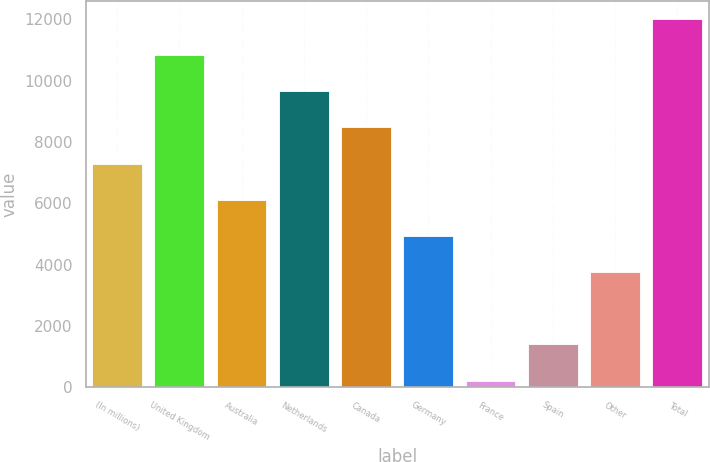Convert chart to OTSL. <chart><loc_0><loc_0><loc_500><loc_500><bar_chart><fcel>(In millions)<fcel>United Kingdom<fcel>Australia<fcel>Netherlands<fcel>Canada<fcel>Germany<fcel>France<fcel>Spain<fcel>Other<fcel>Total<nl><fcel>7297.8<fcel>10837.2<fcel>6118<fcel>9657.4<fcel>8477.6<fcel>4938.2<fcel>219<fcel>1398.8<fcel>3758.4<fcel>12017<nl></chart> 